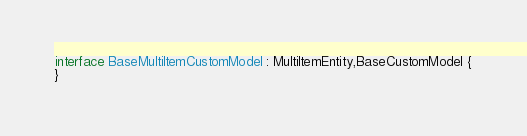Convert code to text. <code><loc_0><loc_0><loc_500><loc_500><_Kotlin_>
interface BaseMultiItemCustomModel : MultiItemEntity,BaseCustomModel {
}</code> 